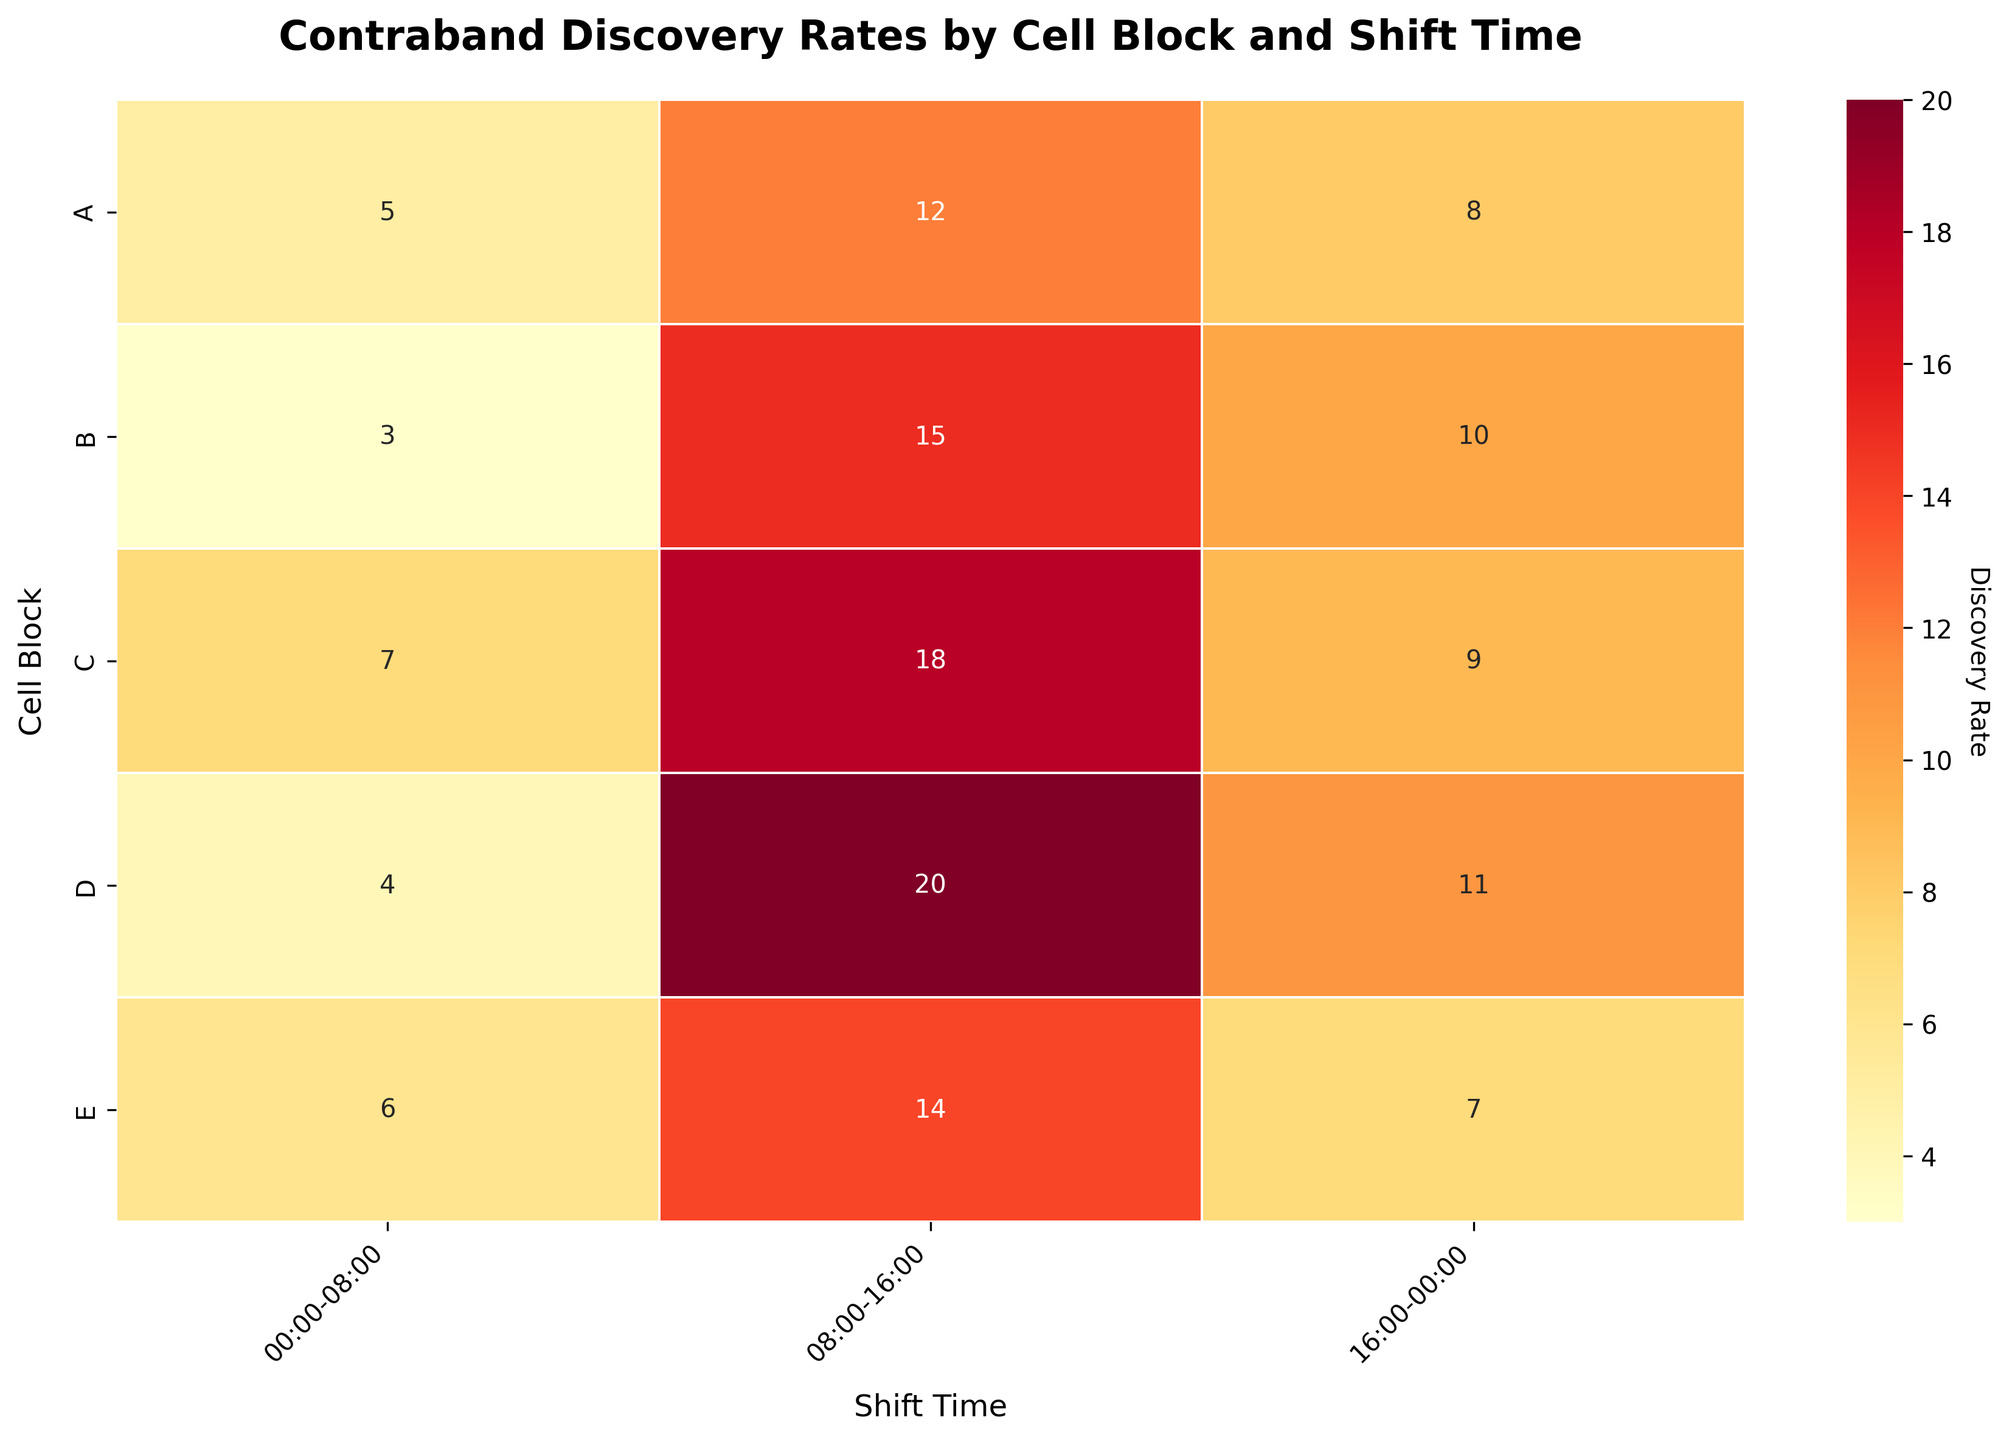What is the title of the heatmap? The title is located at the top of the figure, which provides a summary of what the heatmap represents.
Answer: Contraband Discovery Rates by Cell Block and Shift Time Which cell block has the highest contraband discovery rate during the 08:00-16:00 shift? Locate the column for the 08:00-16:00 shift and identify the highest value within that column.
Answer: Cell Block D What is the contraband discovery rate for Cell Block C during the 16:00-00:00 shift? Find the row for Cell Block C and the column for the 16:00-00:00 shift, then note the value at their intersection.
Answer: 9 Which shift has the highest average contraband discovery rate? Calculate the average discovery rate for each shift by summing the values in each column and dividing by the number of cell blocks, then compare the averages.
Answer: 08:00-16:00 Compare the contraband discovery rates between Cell Block B and Cell Block E during the 00:00-08:00 shift. Which one is higher? Find the value for each block in the 00:00-08:00 shift and compare them.
Answer: Cell Block E What is the total contraband discovery rate for Cell Block A across all shifts? Sum the values for Cell Block A across all shift columns.
Answer: 25 Which Cell Block has the lowest contraband discovery rate during the 00:00-08:00 shift? Identify the smallest value in the column for the 00:00-08:00 shift.
Answer: Cell Block B By how much does the contraband discovery rate for Cell Block D during the 08:00-16:00 shift exceed that during the 00:00-08:00 shift? Subtract the contraband rate for the 00:00-08:00 shift from that of the 08:00-16:00 shift for Cell Block D.
Answer: 16 What is the average contraband discovery rate for Cell Blocks C and E during the 08:00-16:00 shift? Find the values for Cell Blocks C and E in the 08:00-16:00 shift column, sum them, and divide by 2.
Answer: 16 Which Cell Block has the most consistent discovery rates across all shifts (i.e., the smallest range between maximum and minimum rates)? Calculate the range (maximum rate - minimum rate) for each block and identify the smallest range.
Answer: Cell Block E 